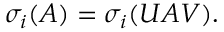Convert formula to latex. <formula><loc_0><loc_0><loc_500><loc_500>\sigma _ { i } ( A ) = \sigma _ { i } ( U A V ) .</formula> 